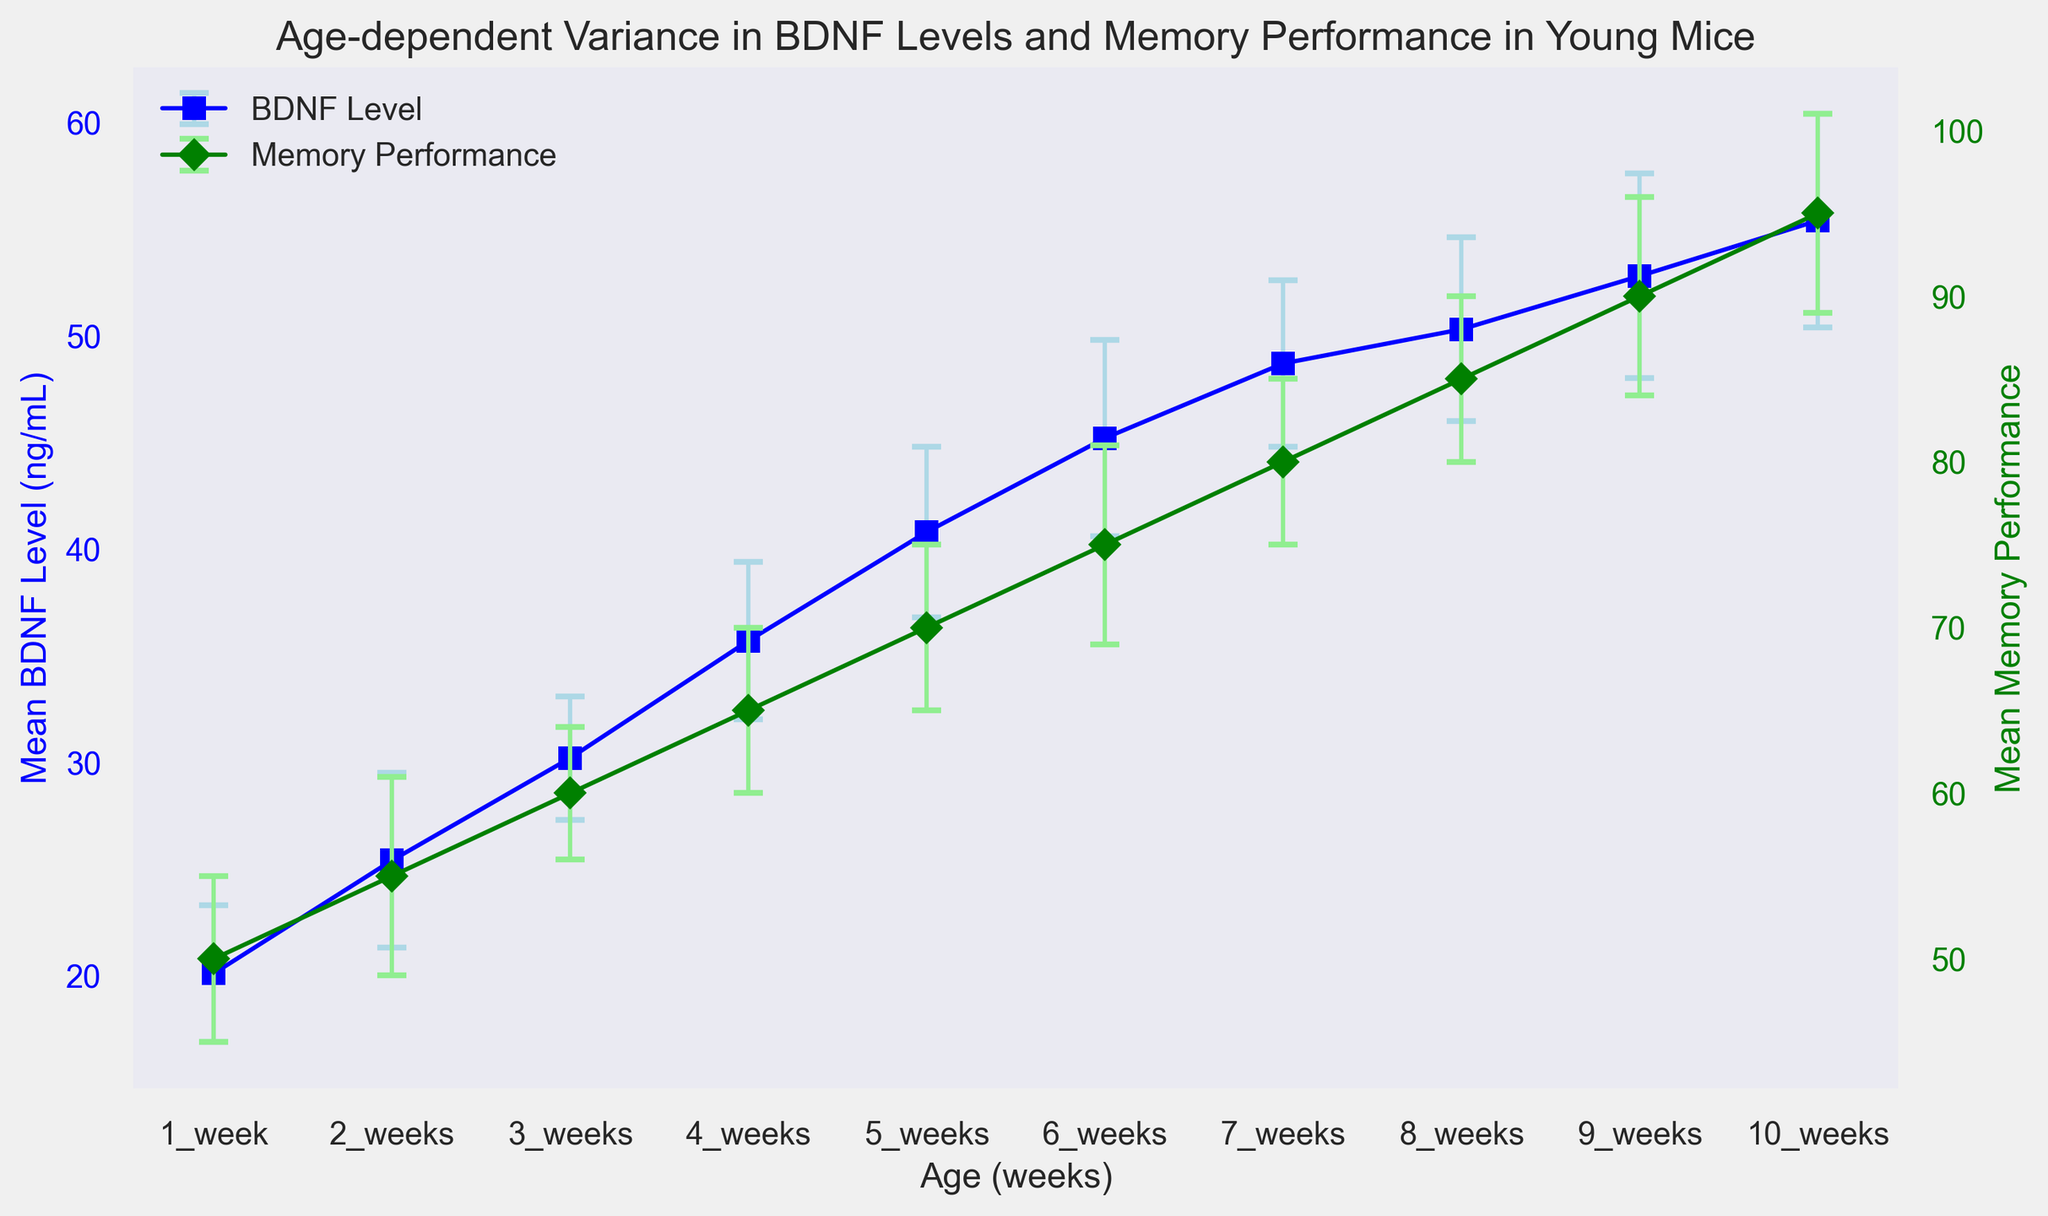Which age group has the highest Mean BDNF Level? Look at the blue line and markers representing Mean BDNF Level across different ages. The highest point on this line is at 10 weeks.
Answer: 10 weeks Which age group has the lowest Mean Memory Performance? Examine the green line and markers representing Mean Memory Performance. The lowest point on the green line is at 1 week.
Answer: 1 week What is the relationship between Mean BDNF Level and Mean Memory Performance at 5 weeks? At 5 weeks, the blue marker for Mean BDNF Level is at 40.8 ng/mL, and the green marker for Mean Memory Performance is at 70. Both increase at similar rates.
Answer: Both increase What is the difference in Mean BDNF Level between 4 weeks and 6 weeks? Determine the Mean BDNF Level at 6 weeks (45.2 ng/mL) and 4 weeks (35.7 ng/mL). Subtract the value at 4 weeks from that at 6 weeks: 45.2 - 35.7 = 9.5 ng/mL.
Answer: 9.5 ng/mL How does the standard deviation for Mean Memory Performance change from 1 week to 10 weeks? Compare the standard deviation values for Mean Memory Performance at 1 week (5) and 10 weeks (6). The standard deviation increases by 1 from 1 week to 10 weeks.
Answer: Increases At what age do the standard deviations of Mean BDNF Level and Mean Memory Performance both reach their maximum values? Identify the ages where the error bars (standard deviations) are the longest for both Mean BDNF Level and Mean Memory Performance. Both achieve maximum values at 10 weeks, with standard deviations of 5.0 ng/mL and 6, respectively.
Answer: 10 weeks Between 7 weeks and 8 weeks, which parameter shows a larger increase in its mean value: BDNF Level or Memory Performance? Calculate the difference in BDNF Level: 50.3 - 48.7 = 1.6 ng/mL. Calculate the difference in Memory Performance: 85 - 80 = 5. Memory Performance shows a larger increase.
Answer: Memory Performance How would you describe the overall trend in Mean BDNF Level from 1 to 10 weeks? Inspect the blue line from 1 week to 10 weeks. The Mean BDNF Level consistently increases over this period.
Answer: Increases Is there a specific week where Mean BDNF Level and Mean Memory Performance are equal? Compare the values of Mean BDNF Level and Mean Memory Performance for each week. There is no week where the two mean values are equal.
Answer: No 